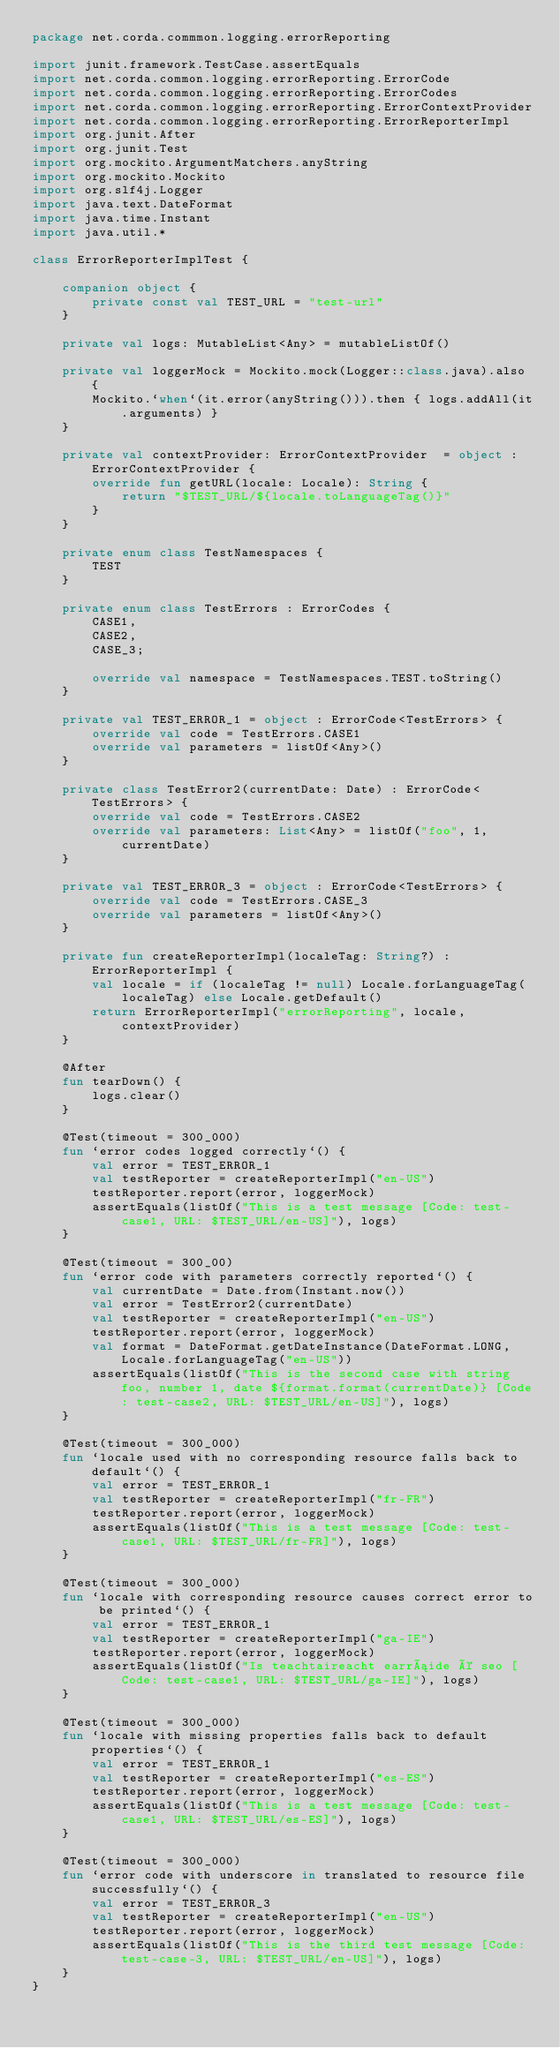Convert code to text. <code><loc_0><loc_0><loc_500><loc_500><_Kotlin_>package net.corda.commmon.logging.errorReporting

import junit.framework.TestCase.assertEquals
import net.corda.common.logging.errorReporting.ErrorCode
import net.corda.common.logging.errorReporting.ErrorCodes
import net.corda.common.logging.errorReporting.ErrorContextProvider
import net.corda.common.logging.errorReporting.ErrorReporterImpl
import org.junit.After
import org.junit.Test
import org.mockito.ArgumentMatchers.anyString
import org.mockito.Mockito
import org.slf4j.Logger
import java.text.DateFormat
import java.time.Instant
import java.util.*

class ErrorReporterImplTest {

    companion object {
        private const val TEST_URL = "test-url"
    }

    private val logs: MutableList<Any> = mutableListOf()

    private val loggerMock = Mockito.mock(Logger::class.java).also {
        Mockito.`when`(it.error(anyString())).then { logs.addAll(it.arguments) }
    }

    private val contextProvider: ErrorContextProvider  = object : ErrorContextProvider {
        override fun getURL(locale: Locale): String {
            return "$TEST_URL/${locale.toLanguageTag()}"
        }
    }

    private enum class TestNamespaces {
        TEST
    }

    private enum class TestErrors : ErrorCodes {
        CASE1,
        CASE2,
        CASE_3;

        override val namespace = TestNamespaces.TEST.toString()
    }

    private val TEST_ERROR_1 = object : ErrorCode<TestErrors> {
        override val code = TestErrors.CASE1
        override val parameters = listOf<Any>()
    }

    private class TestError2(currentDate: Date) : ErrorCode<TestErrors> {
        override val code = TestErrors.CASE2
        override val parameters: List<Any> = listOf("foo", 1, currentDate)
    }

    private val TEST_ERROR_3 = object : ErrorCode<TestErrors> {
        override val code = TestErrors.CASE_3
        override val parameters = listOf<Any>()
    }

    private fun createReporterImpl(localeTag: String?) : ErrorReporterImpl {
        val locale = if (localeTag != null) Locale.forLanguageTag(localeTag) else Locale.getDefault()
        return ErrorReporterImpl("errorReporting", locale, contextProvider)
    }

    @After
    fun tearDown() {
        logs.clear()
    }

    @Test(timeout = 300_000)
    fun `error codes logged correctly`() {
        val error = TEST_ERROR_1
        val testReporter = createReporterImpl("en-US")
        testReporter.report(error, loggerMock)
        assertEquals(listOf("This is a test message [Code: test-case1, URL: $TEST_URL/en-US]"), logs)
    }

    @Test(timeout = 300_00)
    fun `error code with parameters correctly reported`() {
        val currentDate = Date.from(Instant.now())
        val error = TestError2(currentDate)
        val testReporter = createReporterImpl("en-US")
        testReporter.report(error, loggerMock)
        val format = DateFormat.getDateInstance(DateFormat.LONG, Locale.forLanguageTag("en-US"))
        assertEquals(listOf("This is the second case with string foo, number 1, date ${format.format(currentDate)} [Code: test-case2, URL: $TEST_URL/en-US]"), logs)
    }

    @Test(timeout = 300_000)
    fun `locale used with no corresponding resource falls back to default`() {
        val error = TEST_ERROR_1
        val testReporter = createReporterImpl("fr-FR")
        testReporter.report(error, loggerMock)
        assertEquals(listOf("This is a test message [Code: test-case1, URL: $TEST_URL/fr-FR]"), logs)
    }

    @Test(timeout = 300_000)
    fun `locale with corresponding resource causes correct error to be printed`() {
        val error = TEST_ERROR_1
        val testReporter = createReporterImpl("ga-IE")
        testReporter.report(error, loggerMock)
        assertEquals(listOf("Is teachtaireacht earráide é seo [Code: test-case1, URL: $TEST_URL/ga-IE]"), logs)
    }

    @Test(timeout = 300_000)
    fun `locale with missing properties falls back to default properties`() {
        val error = TEST_ERROR_1
        val testReporter = createReporterImpl("es-ES")
        testReporter.report(error, loggerMock)
        assertEquals(listOf("This is a test message [Code: test-case1, URL: $TEST_URL/es-ES]"), logs)
    }

    @Test(timeout = 300_000)
    fun `error code with underscore in translated to resource file successfully`() {
        val error = TEST_ERROR_3
        val testReporter = createReporterImpl("en-US")
        testReporter.report(error, loggerMock)
        assertEquals(listOf("This is the third test message [Code: test-case-3, URL: $TEST_URL/en-US]"), logs)
    }
}</code> 